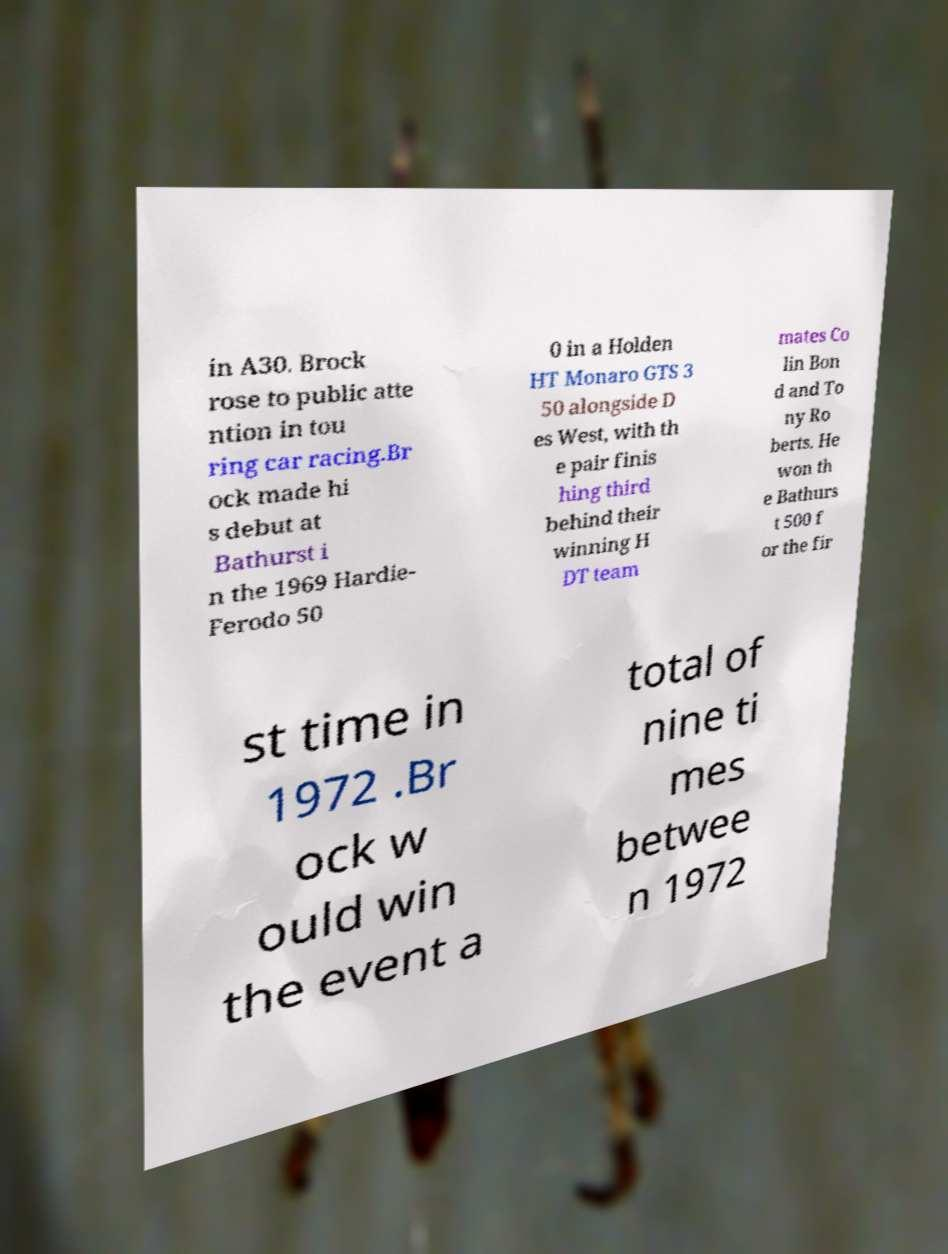I need the written content from this picture converted into text. Can you do that? in A30. Brock rose to public atte ntion in tou ring car racing.Br ock made hi s debut at Bathurst i n the 1969 Hardie- Ferodo 50 0 in a Holden HT Monaro GTS 3 50 alongside D es West, with th e pair finis hing third behind their winning H DT team mates Co lin Bon d and To ny Ro berts. He won th e Bathurs t 500 f or the fir st time in 1972 .Br ock w ould win the event a total of nine ti mes betwee n 1972 